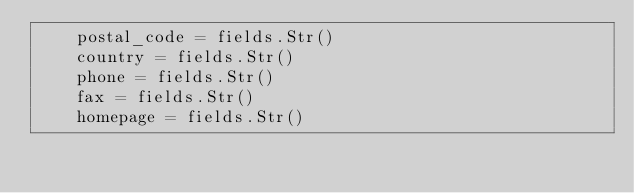Convert code to text. <code><loc_0><loc_0><loc_500><loc_500><_Python_>    postal_code = fields.Str()
    country = fields.Str()
    phone = fields.Str()
    fax = fields.Str()
    homepage = fields.Str()
</code> 